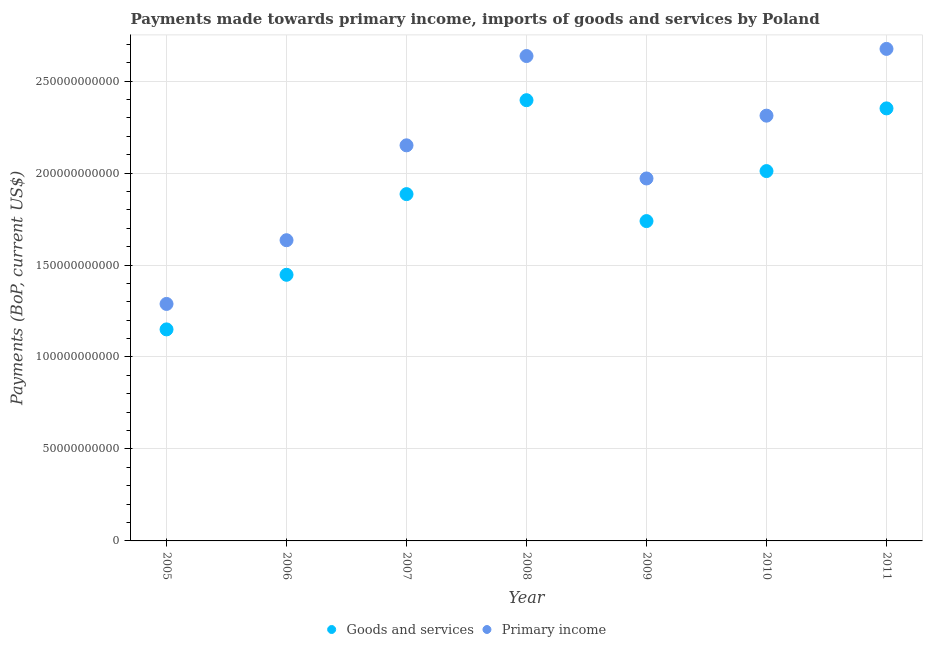How many different coloured dotlines are there?
Your answer should be very brief. 2. Is the number of dotlines equal to the number of legend labels?
Give a very brief answer. Yes. What is the payments made towards primary income in 2006?
Your answer should be compact. 1.63e+11. Across all years, what is the maximum payments made towards primary income?
Offer a terse response. 2.68e+11. Across all years, what is the minimum payments made towards primary income?
Offer a terse response. 1.29e+11. What is the total payments made towards goods and services in the graph?
Your answer should be compact. 1.30e+12. What is the difference between the payments made towards goods and services in 2005 and that in 2006?
Give a very brief answer. -2.97e+1. What is the difference between the payments made towards goods and services in 2006 and the payments made towards primary income in 2008?
Ensure brevity in your answer.  -1.19e+11. What is the average payments made towards goods and services per year?
Your answer should be compact. 1.85e+11. In the year 2005, what is the difference between the payments made towards primary income and payments made towards goods and services?
Give a very brief answer. 1.38e+1. In how many years, is the payments made towards primary income greater than 150000000000 US$?
Your answer should be very brief. 6. What is the ratio of the payments made towards goods and services in 2007 to that in 2011?
Ensure brevity in your answer.  0.8. Is the payments made towards primary income in 2007 less than that in 2011?
Offer a very short reply. Yes. What is the difference between the highest and the second highest payments made towards goods and services?
Provide a short and direct response. 4.46e+09. What is the difference between the highest and the lowest payments made towards primary income?
Your answer should be very brief. 1.39e+11. In how many years, is the payments made towards goods and services greater than the average payments made towards goods and services taken over all years?
Provide a succinct answer. 4. Is the sum of the payments made towards primary income in 2007 and 2011 greater than the maximum payments made towards goods and services across all years?
Offer a very short reply. Yes. Does the payments made towards primary income monotonically increase over the years?
Provide a short and direct response. No. Are the values on the major ticks of Y-axis written in scientific E-notation?
Provide a succinct answer. No. Does the graph contain grids?
Keep it short and to the point. Yes. How many legend labels are there?
Offer a very short reply. 2. How are the legend labels stacked?
Your answer should be very brief. Horizontal. What is the title of the graph?
Ensure brevity in your answer.  Payments made towards primary income, imports of goods and services by Poland. Does "Secondary education" appear as one of the legend labels in the graph?
Offer a terse response. No. What is the label or title of the X-axis?
Provide a short and direct response. Year. What is the label or title of the Y-axis?
Your answer should be compact. Payments (BoP, current US$). What is the Payments (BoP, current US$) of Goods and services in 2005?
Offer a very short reply. 1.15e+11. What is the Payments (BoP, current US$) in Primary income in 2005?
Offer a very short reply. 1.29e+11. What is the Payments (BoP, current US$) of Goods and services in 2006?
Keep it short and to the point. 1.45e+11. What is the Payments (BoP, current US$) of Primary income in 2006?
Ensure brevity in your answer.  1.63e+11. What is the Payments (BoP, current US$) of Goods and services in 2007?
Make the answer very short. 1.89e+11. What is the Payments (BoP, current US$) in Primary income in 2007?
Your response must be concise. 2.15e+11. What is the Payments (BoP, current US$) in Goods and services in 2008?
Make the answer very short. 2.40e+11. What is the Payments (BoP, current US$) of Primary income in 2008?
Your answer should be compact. 2.64e+11. What is the Payments (BoP, current US$) of Goods and services in 2009?
Provide a short and direct response. 1.74e+11. What is the Payments (BoP, current US$) in Primary income in 2009?
Offer a very short reply. 1.97e+11. What is the Payments (BoP, current US$) in Goods and services in 2010?
Your response must be concise. 2.01e+11. What is the Payments (BoP, current US$) of Primary income in 2010?
Your response must be concise. 2.31e+11. What is the Payments (BoP, current US$) in Goods and services in 2011?
Ensure brevity in your answer.  2.35e+11. What is the Payments (BoP, current US$) of Primary income in 2011?
Your answer should be very brief. 2.68e+11. Across all years, what is the maximum Payments (BoP, current US$) in Goods and services?
Keep it short and to the point. 2.40e+11. Across all years, what is the maximum Payments (BoP, current US$) of Primary income?
Your answer should be very brief. 2.68e+11. Across all years, what is the minimum Payments (BoP, current US$) in Goods and services?
Your answer should be very brief. 1.15e+11. Across all years, what is the minimum Payments (BoP, current US$) of Primary income?
Offer a very short reply. 1.29e+11. What is the total Payments (BoP, current US$) in Goods and services in the graph?
Make the answer very short. 1.30e+12. What is the total Payments (BoP, current US$) in Primary income in the graph?
Give a very brief answer. 1.47e+12. What is the difference between the Payments (BoP, current US$) of Goods and services in 2005 and that in 2006?
Offer a terse response. -2.97e+1. What is the difference between the Payments (BoP, current US$) of Primary income in 2005 and that in 2006?
Your answer should be very brief. -3.46e+1. What is the difference between the Payments (BoP, current US$) of Goods and services in 2005 and that in 2007?
Provide a short and direct response. -7.35e+1. What is the difference between the Payments (BoP, current US$) in Primary income in 2005 and that in 2007?
Your answer should be very brief. -8.62e+1. What is the difference between the Payments (BoP, current US$) in Goods and services in 2005 and that in 2008?
Provide a succinct answer. -1.25e+11. What is the difference between the Payments (BoP, current US$) in Primary income in 2005 and that in 2008?
Your answer should be compact. -1.35e+11. What is the difference between the Payments (BoP, current US$) in Goods and services in 2005 and that in 2009?
Provide a succinct answer. -5.89e+1. What is the difference between the Payments (BoP, current US$) in Primary income in 2005 and that in 2009?
Your answer should be very brief. -6.82e+1. What is the difference between the Payments (BoP, current US$) in Goods and services in 2005 and that in 2010?
Your answer should be very brief. -8.61e+1. What is the difference between the Payments (BoP, current US$) of Primary income in 2005 and that in 2010?
Your answer should be compact. -1.02e+11. What is the difference between the Payments (BoP, current US$) of Goods and services in 2005 and that in 2011?
Ensure brevity in your answer.  -1.20e+11. What is the difference between the Payments (BoP, current US$) of Primary income in 2005 and that in 2011?
Your response must be concise. -1.39e+11. What is the difference between the Payments (BoP, current US$) in Goods and services in 2006 and that in 2007?
Offer a very short reply. -4.39e+1. What is the difference between the Payments (BoP, current US$) in Primary income in 2006 and that in 2007?
Make the answer very short. -5.16e+1. What is the difference between the Payments (BoP, current US$) in Goods and services in 2006 and that in 2008?
Your answer should be compact. -9.49e+1. What is the difference between the Payments (BoP, current US$) in Primary income in 2006 and that in 2008?
Make the answer very short. -1.00e+11. What is the difference between the Payments (BoP, current US$) of Goods and services in 2006 and that in 2009?
Make the answer very short. -2.92e+1. What is the difference between the Payments (BoP, current US$) in Primary income in 2006 and that in 2009?
Your response must be concise. -3.36e+1. What is the difference between the Payments (BoP, current US$) in Goods and services in 2006 and that in 2010?
Ensure brevity in your answer.  -5.64e+1. What is the difference between the Payments (BoP, current US$) of Primary income in 2006 and that in 2010?
Your answer should be very brief. -6.77e+1. What is the difference between the Payments (BoP, current US$) in Goods and services in 2006 and that in 2011?
Keep it short and to the point. -9.05e+1. What is the difference between the Payments (BoP, current US$) of Primary income in 2006 and that in 2011?
Your answer should be compact. -1.04e+11. What is the difference between the Payments (BoP, current US$) of Goods and services in 2007 and that in 2008?
Your answer should be compact. -5.11e+1. What is the difference between the Payments (BoP, current US$) of Primary income in 2007 and that in 2008?
Offer a terse response. -4.86e+1. What is the difference between the Payments (BoP, current US$) in Goods and services in 2007 and that in 2009?
Provide a succinct answer. 1.47e+1. What is the difference between the Payments (BoP, current US$) in Primary income in 2007 and that in 2009?
Offer a very short reply. 1.80e+1. What is the difference between the Payments (BoP, current US$) of Goods and services in 2007 and that in 2010?
Offer a very short reply. -1.25e+1. What is the difference between the Payments (BoP, current US$) in Primary income in 2007 and that in 2010?
Give a very brief answer. -1.61e+1. What is the difference between the Payments (BoP, current US$) of Goods and services in 2007 and that in 2011?
Keep it short and to the point. -4.66e+1. What is the difference between the Payments (BoP, current US$) of Primary income in 2007 and that in 2011?
Offer a terse response. -5.24e+1. What is the difference between the Payments (BoP, current US$) of Goods and services in 2008 and that in 2009?
Provide a short and direct response. 6.57e+1. What is the difference between the Payments (BoP, current US$) of Primary income in 2008 and that in 2009?
Give a very brief answer. 6.66e+1. What is the difference between the Payments (BoP, current US$) in Goods and services in 2008 and that in 2010?
Give a very brief answer. 3.85e+1. What is the difference between the Payments (BoP, current US$) in Primary income in 2008 and that in 2010?
Your response must be concise. 3.24e+1. What is the difference between the Payments (BoP, current US$) in Goods and services in 2008 and that in 2011?
Give a very brief answer. 4.46e+09. What is the difference between the Payments (BoP, current US$) in Primary income in 2008 and that in 2011?
Make the answer very short. -3.88e+09. What is the difference between the Payments (BoP, current US$) in Goods and services in 2009 and that in 2010?
Provide a succinct answer. -2.72e+1. What is the difference between the Payments (BoP, current US$) of Primary income in 2009 and that in 2010?
Offer a terse response. -3.42e+1. What is the difference between the Payments (BoP, current US$) in Goods and services in 2009 and that in 2011?
Offer a very short reply. -6.13e+1. What is the difference between the Payments (BoP, current US$) in Primary income in 2009 and that in 2011?
Your answer should be compact. -7.04e+1. What is the difference between the Payments (BoP, current US$) of Goods and services in 2010 and that in 2011?
Make the answer very short. -3.41e+1. What is the difference between the Payments (BoP, current US$) of Primary income in 2010 and that in 2011?
Provide a short and direct response. -3.63e+1. What is the difference between the Payments (BoP, current US$) of Goods and services in 2005 and the Payments (BoP, current US$) of Primary income in 2006?
Provide a short and direct response. -4.85e+1. What is the difference between the Payments (BoP, current US$) in Goods and services in 2005 and the Payments (BoP, current US$) in Primary income in 2007?
Your response must be concise. -1.00e+11. What is the difference between the Payments (BoP, current US$) of Goods and services in 2005 and the Payments (BoP, current US$) of Primary income in 2008?
Offer a very short reply. -1.49e+11. What is the difference between the Payments (BoP, current US$) in Goods and services in 2005 and the Payments (BoP, current US$) in Primary income in 2009?
Keep it short and to the point. -8.21e+1. What is the difference between the Payments (BoP, current US$) of Goods and services in 2005 and the Payments (BoP, current US$) of Primary income in 2010?
Your response must be concise. -1.16e+11. What is the difference between the Payments (BoP, current US$) in Goods and services in 2005 and the Payments (BoP, current US$) in Primary income in 2011?
Your answer should be compact. -1.53e+11. What is the difference between the Payments (BoP, current US$) in Goods and services in 2006 and the Payments (BoP, current US$) in Primary income in 2007?
Ensure brevity in your answer.  -7.04e+1. What is the difference between the Payments (BoP, current US$) of Goods and services in 2006 and the Payments (BoP, current US$) of Primary income in 2008?
Provide a short and direct response. -1.19e+11. What is the difference between the Payments (BoP, current US$) in Goods and services in 2006 and the Payments (BoP, current US$) in Primary income in 2009?
Provide a short and direct response. -5.24e+1. What is the difference between the Payments (BoP, current US$) of Goods and services in 2006 and the Payments (BoP, current US$) of Primary income in 2010?
Your response must be concise. -8.65e+1. What is the difference between the Payments (BoP, current US$) of Goods and services in 2006 and the Payments (BoP, current US$) of Primary income in 2011?
Your response must be concise. -1.23e+11. What is the difference between the Payments (BoP, current US$) in Goods and services in 2007 and the Payments (BoP, current US$) in Primary income in 2008?
Offer a very short reply. -7.51e+1. What is the difference between the Payments (BoP, current US$) of Goods and services in 2007 and the Payments (BoP, current US$) of Primary income in 2009?
Provide a short and direct response. -8.51e+09. What is the difference between the Payments (BoP, current US$) of Goods and services in 2007 and the Payments (BoP, current US$) of Primary income in 2010?
Make the answer very short. -4.27e+1. What is the difference between the Payments (BoP, current US$) of Goods and services in 2007 and the Payments (BoP, current US$) of Primary income in 2011?
Give a very brief answer. -7.90e+1. What is the difference between the Payments (BoP, current US$) of Goods and services in 2008 and the Payments (BoP, current US$) of Primary income in 2009?
Your answer should be very brief. 4.26e+1. What is the difference between the Payments (BoP, current US$) in Goods and services in 2008 and the Payments (BoP, current US$) in Primary income in 2010?
Offer a terse response. 8.41e+09. What is the difference between the Payments (BoP, current US$) in Goods and services in 2008 and the Payments (BoP, current US$) in Primary income in 2011?
Ensure brevity in your answer.  -2.79e+1. What is the difference between the Payments (BoP, current US$) in Goods and services in 2009 and the Payments (BoP, current US$) in Primary income in 2010?
Offer a very short reply. -5.73e+1. What is the difference between the Payments (BoP, current US$) in Goods and services in 2009 and the Payments (BoP, current US$) in Primary income in 2011?
Your answer should be very brief. -9.36e+1. What is the difference between the Payments (BoP, current US$) of Goods and services in 2010 and the Payments (BoP, current US$) of Primary income in 2011?
Your answer should be very brief. -6.64e+1. What is the average Payments (BoP, current US$) in Goods and services per year?
Provide a short and direct response. 1.85e+11. What is the average Payments (BoP, current US$) in Primary income per year?
Make the answer very short. 2.10e+11. In the year 2005, what is the difference between the Payments (BoP, current US$) of Goods and services and Payments (BoP, current US$) of Primary income?
Offer a very short reply. -1.38e+1. In the year 2006, what is the difference between the Payments (BoP, current US$) in Goods and services and Payments (BoP, current US$) in Primary income?
Give a very brief answer. -1.88e+1. In the year 2007, what is the difference between the Payments (BoP, current US$) of Goods and services and Payments (BoP, current US$) of Primary income?
Your answer should be compact. -2.65e+1. In the year 2008, what is the difference between the Payments (BoP, current US$) in Goods and services and Payments (BoP, current US$) in Primary income?
Your answer should be compact. -2.40e+1. In the year 2009, what is the difference between the Payments (BoP, current US$) in Goods and services and Payments (BoP, current US$) in Primary income?
Offer a terse response. -2.32e+1. In the year 2010, what is the difference between the Payments (BoP, current US$) in Goods and services and Payments (BoP, current US$) in Primary income?
Offer a very short reply. -3.01e+1. In the year 2011, what is the difference between the Payments (BoP, current US$) of Goods and services and Payments (BoP, current US$) of Primary income?
Give a very brief answer. -3.23e+1. What is the ratio of the Payments (BoP, current US$) of Goods and services in 2005 to that in 2006?
Your response must be concise. 0.79. What is the ratio of the Payments (BoP, current US$) of Primary income in 2005 to that in 2006?
Give a very brief answer. 0.79. What is the ratio of the Payments (BoP, current US$) in Goods and services in 2005 to that in 2007?
Offer a very short reply. 0.61. What is the ratio of the Payments (BoP, current US$) in Primary income in 2005 to that in 2007?
Your response must be concise. 0.6. What is the ratio of the Payments (BoP, current US$) in Goods and services in 2005 to that in 2008?
Your response must be concise. 0.48. What is the ratio of the Payments (BoP, current US$) in Primary income in 2005 to that in 2008?
Provide a succinct answer. 0.49. What is the ratio of the Payments (BoP, current US$) of Goods and services in 2005 to that in 2009?
Your answer should be compact. 0.66. What is the ratio of the Payments (BoP, current US$) of Primary income in 2005 to that in 2009?
Provide a succinct answer. 0.65. What is the ratio of the Payments (BoP, current US$) of Goods and services in 2005 to that in 2010?
Your answer should be compact. 0.57. What is the ratio of the Payments (BoP, current US$) of Primary income in 2005 to that in 2010?
Offer a terse response. 0.56. What is the ratio of the Payments (BoP, current US$) in Goods and services in 2005 to that in 2011?
Make the answer very short. 0.49. What is the ratio of the Payments (BoP, current US$) in Primary income in 2005 to that in 2011?
Provide a short and direct response. 0.48. What is the ratio of the Payments (BoP, current US$) of Goods and services in 2006 to that in 2007?
Keep it short and to the point. 0.77. What is the ratio of the Payments (BoP, current US$) in Primary income in 2006 to that in 2007?
Give a very brief answer. 0.76. What is the ratio of the Payments (BoP, current US$) in Goods and services in 2006 to that in 2008?
Your response must be concise. 0.6. What is the ratio of the Payments (BoP, current US$) of Primary income in 2006 to that in 2008?
Give a very brief answer. 0.62. What is the ratio of the Payments (BoP, current US$) of Goods and services in 2006 to that in 2009?
Offer a very short reply. 0.83. What is the ratio of the Payments (BoP, current US$) of Primary income in 2006 to that in 2009?
Your response must be concise. 0.83. What is the ratio of the Payments (BoP, current US$) in Goods and services in 2006 to that in 2010?
Provide a short and direct response. 0.72. What is the ratio of the Payments (BoP, current US$) of Primary income in 2006 to that in 2010?
Offer a very short reply. 0.71. What is the ratio of the Payments (BoP, current US$) in Goods and services in 2006 to that in 2011?
Ensure brevity in your answer.  0.62. What is the ratio of the Payments (BoP, current US$) in Primary income in 2006 to that in 2011?
Provide a succinct answer. 0.61. What is the ratio of the Payments (BoP, current US$) in Goods and services in 2007 to that in 2008?
Your answer should be very brief. 0.79. What is the ratio of the Payments (BoP, current US$) in Primary income in 2007 to that in 2008?
Make the answer very short. 0.82. What is the ratio of the Payments (BoP, current US$) of Goods and services in 2007 to that in 2009?
Provide a short and direct response. 1.08. What is the ratio of the Payments (BoP, current US$) of Primary income in 2007 to that in 2009?
Make the answer very short. 1.09. What is the ratio of the Payments (BoP, current US$) of Goods and services in 2007 to that in 2010?
Keep it short and to the point. 0.94. What is the ratio of the Payments (BoP, current US$) of Primary income in 2007 to that in 2010?
Your response must be concise. 0.93. What is the ratio of the Payments (BoP, current US$) of Goods and services in 2007 to that in 2011?
Offer a very short reply. 0.8. What is the ratio of the Payments (BoP, current US$) in Primary income in 2007 to that in 2011?
Keep it short and to the point. 0.8. What is the ratio of the Payments (BoP, current US$) of Goods and services in 2008 to that in 2009?
Your answer should be very brief. 1.38. What is the ratio of the Payments (BoP, current US$) in Primary income in 2008 to that in 2009?
Your answer should be very brief. 1.34. What is the ratio of the Payments (BoP, current US$) in Goods and services in 2008 to that in 2010?
Ensure brevity in your answer.  1.19. What is the ratio of the Payments (BoP, current US$) of Primary income in 2008 to that in 2010?
Your answer should be very brief. 1.14. What is the ratio of the Payments (BoP, current US$) of Goods and services in 2008 to that in 2011?
Make the answer very short. 1.02. What is the ratio of the Payments (BoP, current US$) of Primary income in 2008 to that in 2011?
Make the answer very short. 0.99. What is the ratio of the Payments (BoP, current US$) of Goods and services in 2009 to that in 2010?
Provide a short and direct response. 0.86. What is the ratio of the Payments (BoP, current US$) of Primary income in 2009 to that in 2010?
Your answer should be very brief. 0.85. What is the ratio of the Payments (BoP, current US$) of Goods and services in 2009 to that in 2011?
Provide a short and direct response. 0.74. What is the ratio of the Payments (BoP, current US$) of Primary income in 2009 to that in 2011?
Offer a terse response. 0.74. What is the ratio of the Payments (BoP, current US$) of Goods and services in 2010 to that in 2011?
Offer a very short reply. 0.85. What is the ratio of the Payments (BoP, current US$) of Primary income in 2010 to that in 2011?
Give a very brief answer. 0.86. What is the difference between the highest and the second highest Payments (BoP, current US$) in Goods and services?
Ensure brevity in your answer.  4.46e+09. What is the difference between the highest and the second highest Payments (BoP, current US$) in Primary income?
Your answer should be compact. 3.88e+09. What is the difference between the highest and the lowest Payments (BoP, current US$) of Goods and services?
Ensure brevity in your answer.  1.25e+11. What is the difference between the highest and the lowest Payments (BoP, current US$) of Primary income?
Provide a short and direct response. 1.39e+11. 